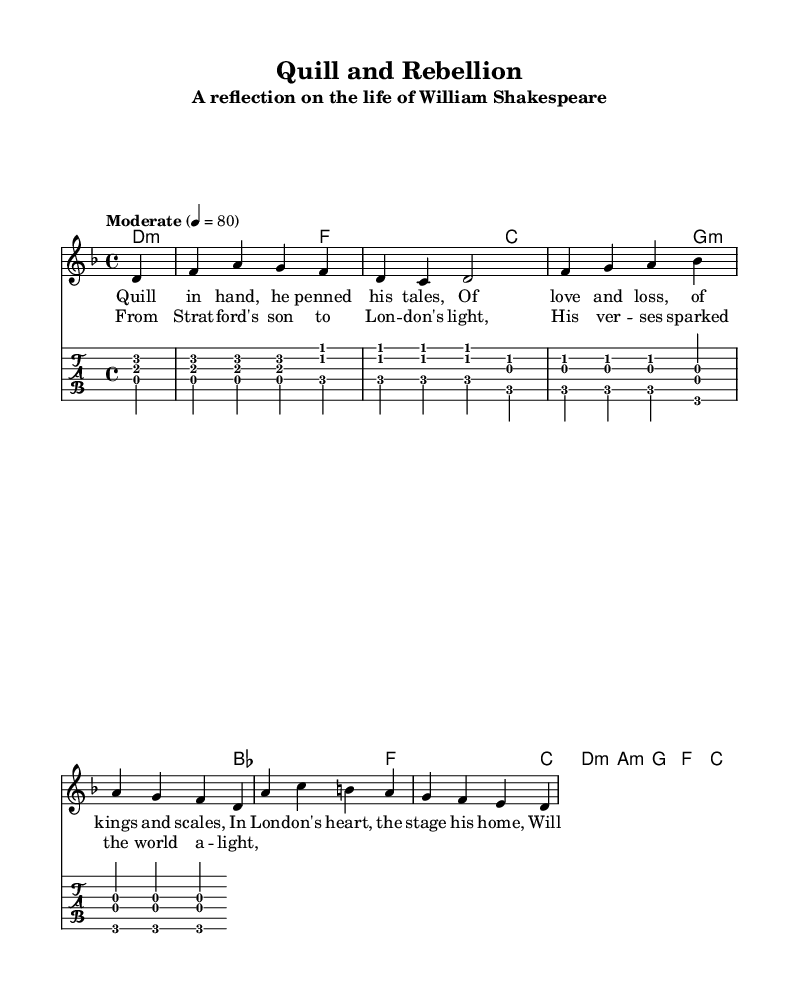What is the key signature of this music? The key signature is identified by looking at the beginning of the staff, where it indicates there are no sharps or flats, representing D minor.
Answer: D minor What is the time signature of this music? The time signature can be found at the beginning of the sheet music, represented by the 4 over 4 format, meaning four beats per measure.
Answer: 4/4 What is the tempo marking of this piece? The tempo is indicated in the score right above the staff with the word "Moderate" and a metronome mark of 4 equals 80, meaning moderate speed.
Answer: Moderate How many measures does the music have? Counting the groupings of notes and the bar lines in the music reveals there are a total of 8 measures.
Answer: 8 What is the name of the piece? The title can be found at the top of the score, specified as "Quill and Rebellion."
Answer: Quill and Rebellion Which famous author is reflected in the lyrics? The lyrics explicitly mention William Shakespeare, indicating the subject of the ballad.
Answer: William Shakespeare What style is this ballad representing? The overall structure and sound, along with thematic aspects, suggest the creation falls under the category of acoustic punk.
Answer: Acoustic punk 